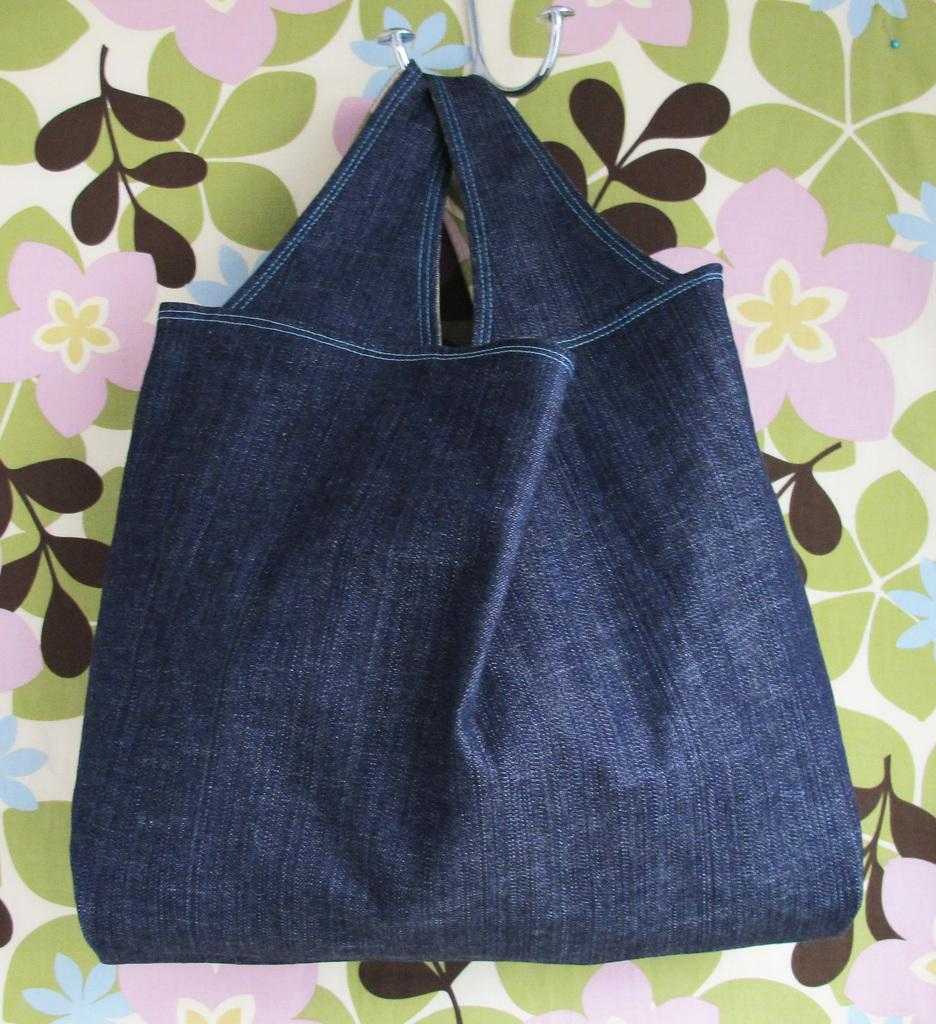What is hanging in the image? There is a bag hanging in the image. What answer can be found in the bag in the image? There is no answer present in the bag in the image, as it is just a hanging bag. What relation does the bag have with the person in the image? There is no person present in the image, so it is not possible to determine any relation between the bag and a person. 